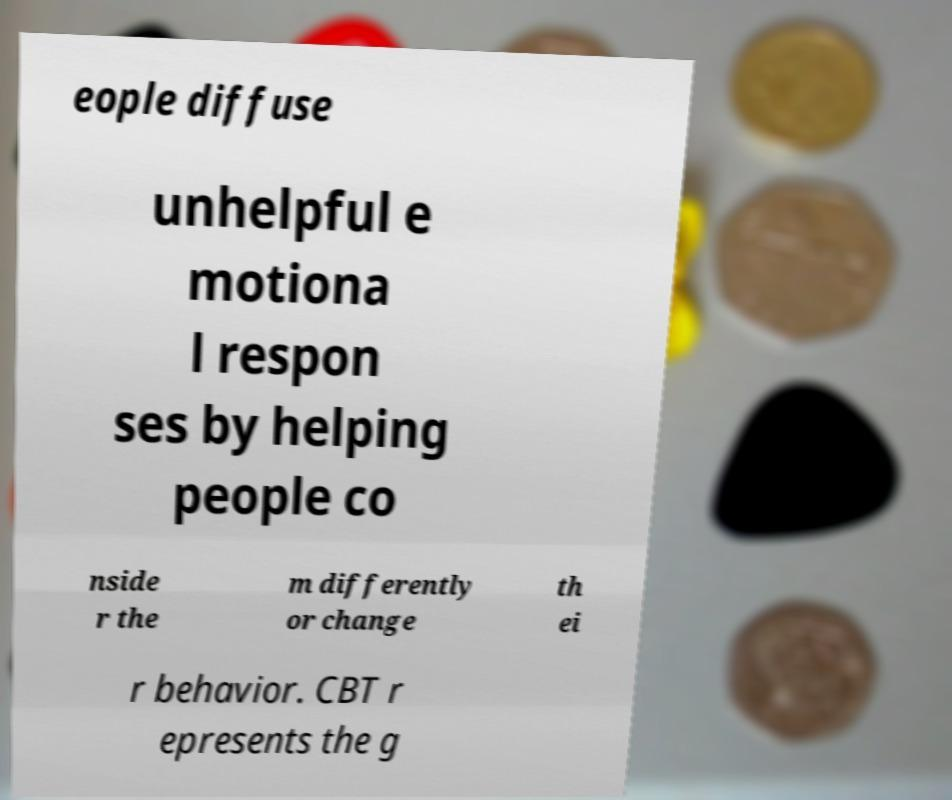There's text embedded in this image that I need extracted. Can you transcribe it verbatim? eople diffuse unhelpful e motiona l respon ses by helping people co nside r the m differently or change th ei r behavior. CBT r epresents the g 